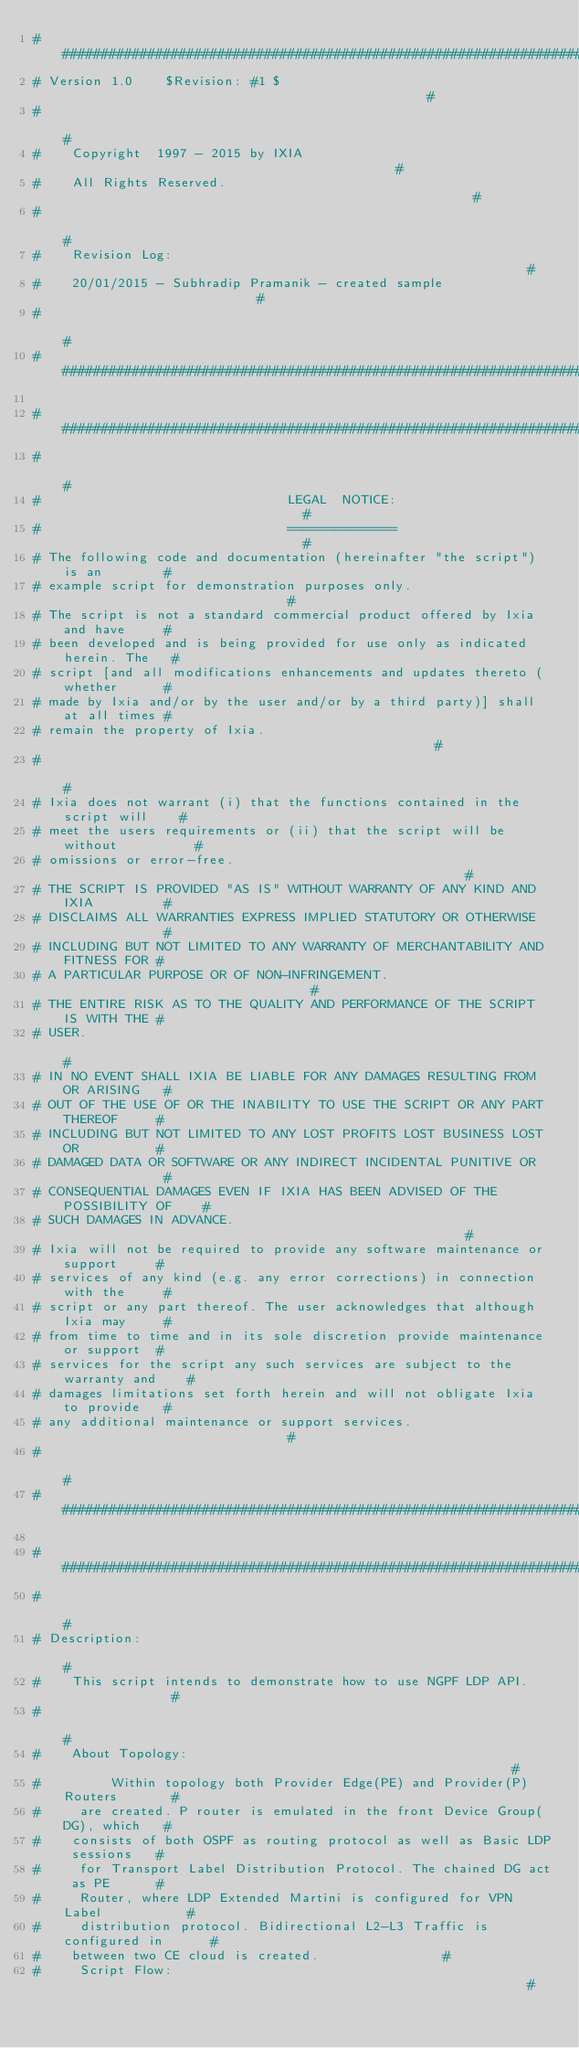<code> <loc_0><loc_0><loc_500><loc_500><_Perl_>################################################################################
# Version 1.0    $Revision: #1 $                                                #
#                                                                              #
#    Copyright  1997 - 2015 by IXIA                                            #
#    All Rights Reserved.                                                      #
#                                                                              #
#    Revision Log:                                                             #
#    20/01/2015 - Subhradip Pramanik - created sample                          #
#                                                                              #
################################################################################

################################################################################
#                                                                              #
#                                LEGAL  NOTICE:                                #
#                                ==============                                #
# The following code and documentation (hereinafter "the script") is an        #
# example script for demonstration purposes only.                              #
# The script is not a standard commercial product offered by Ixia and have     #
# been developed and is being provided for use only as indicated herein. The   #
# script [and all modifications enhancements and updates thereto (whether      #
# made by Ixia and/or by the user and/or by a third party)] shall at all times #
# remain the property of Ixia.                                                 #
#                                                                              #
# Ixia does not warrant (i) that the functions contained in the script will    #
# meet the users requirements or (ii) that the script will be without          #
# omissions or error-free.                                                     #
# THE SCRIPT IS PROVIDED "AS IS" WITHOUT WARRANTY OF ANY KIND AND IXIA         #
# DISCLAIMS ALL WARRANTIES EXPRESS IMPLIED STATUTORY OR OTHERWISE              #
# INCLUDING BUT NOT LIMITED TO ANY WARRANTY OF MERCHANTABILITY AND FITNESS FOR #
# A PARTICULAR PURPOSE OR OF NON-INFRINGEMENT.                                 #
# THE ENTIRE RISK AS TO THE QUALITY AND PERFORMANCE OF THE SCRIPT  IS WITH THE #
# USER.                                                                        #
# IN NO EVENT SHALL IXIA BE LIABLE FOR ANY DAMAGES RESULTING FROM OR ARISING   #
# OUT OF THE USE OF OR THE INABILITY TO USE THE SCRIPT OR ANY PART THEREOF     #
# INCLUDING BUT NOT LIMITED TO ANY LOST PROFITS LOST BUSINESS LOST OR          #
# DAMAGED DATA OR SOFTWARE OR ANY INDIRECT INCIDENTAL PUNITIVE OR              #
# CONSEQUENTIAL DAMAGES EVEN IF IXIA HAS BEEN ADVISED OF THE POSSIBILITY OF    #
# SUCH DAMAGES IN ADVANCE.                                                     #
# Ixia will not be required to provide any software maintenance or support     #
# services of any kind (e.g. any error corrections) in connection with the     #
# script or any part thereof. The user acknowledges that although Ixia may     #
# from time to time and in its sole discretion provide maintenance or support  #
# services for the script any such services are subject to the warranty and    #
# damages limitations set forth herein and will not obligate Ixia to provide   #
# any additional maintenance or support services.                              #
#                                                                              #
################################################################################

################################################################################
#                                                                              #
# Description:                                                                 #
#    This script intends to demonstrate how to use NGPF LDP API.               #
#                                                                              #
#    About Topology:                                                           #
#         Within topology both Provider Edge(PE) and Provider(P) Routers       #
#     are created. P router is emulated in the front Device Group(DG), which   #
#    consists of both OSPF as routing protocol as well as Basic LDP sessions   #
#     for Transport Label Distribution Protocol. The chained DG act as PE      #
#     Router, where LDP Extended Martini is configured for VPN Label           #
#     distribution protocol. Bidirectional L2-L3 Traffic is configured in      #
#    between two CE cloud is created.                #
#     Script Flow:                                                             #</code> 